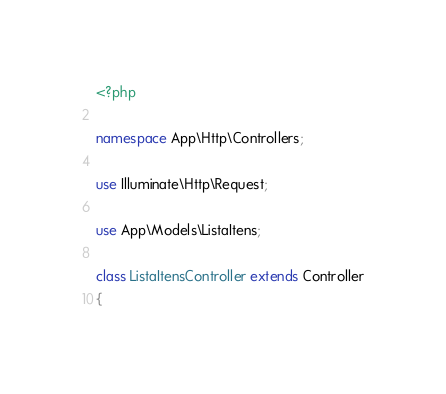<code> <loc_0><loc_0><loc_500><loc_500><_PHP_><?php

namespace App\Http\Controllers;

use Illuminate\Http\Request;

use App\Models\ListaItens;

class ListaItensController extends Controller
{</code> 